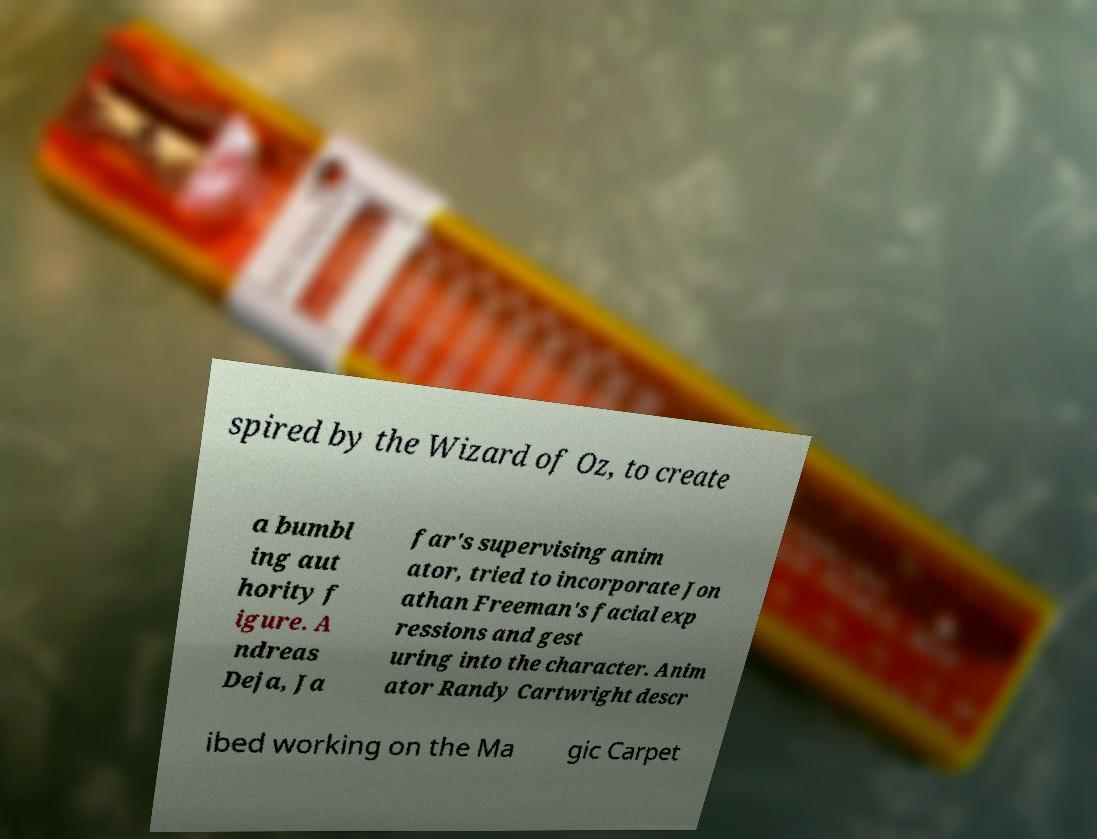For documentation purposes, I need the text within this image transcribed. Could you provide that? spired by the Wizard of Oz, to create a bumbl ing aut hority f igure. A ndreas Deja, Ja far's supervising anim ator, tried to incorporate Jon athan Freeman's facial exp ressions and gest uring into the character. Anim ator Randy Cartwright descr ibed working on the Ma gic Carpet 